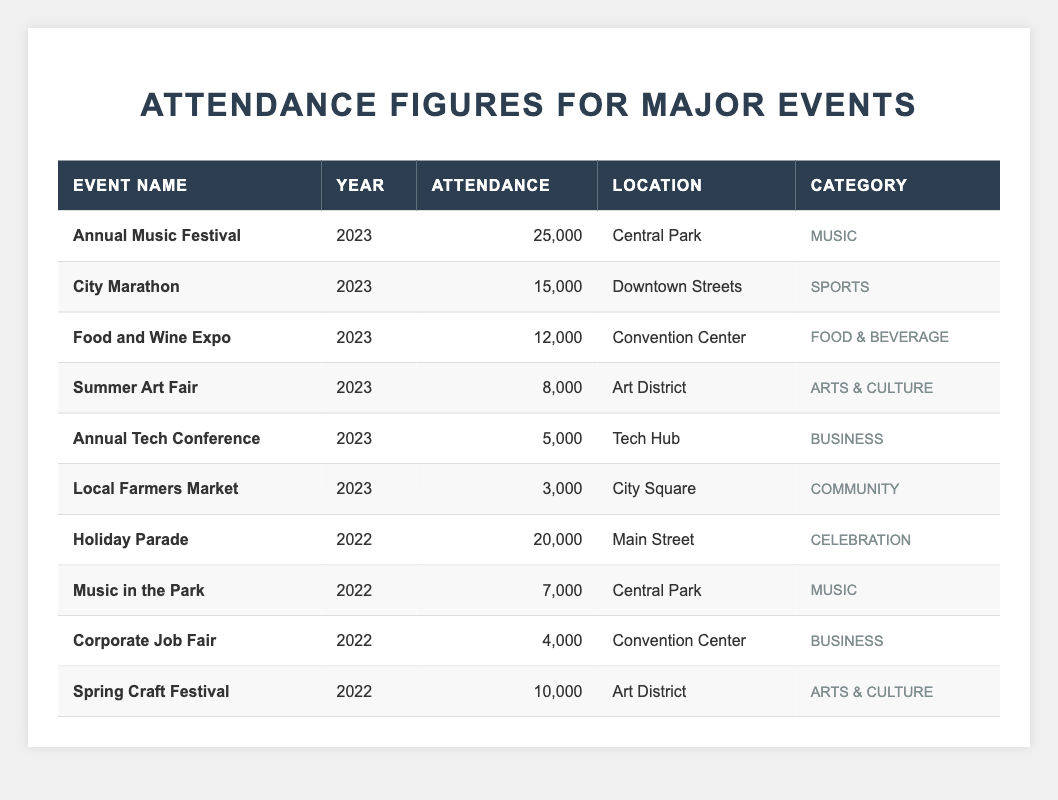What's the attendance for the Annual Music Festival in 2023? The attendance figure for the Annual Music Festival in 2023 can be found directly in the table under the "Attendance" column next to the event name. It shows a figure of 25,000.
Answer: 25,000 Which event had the highest attendance in 2022? By scanning the table, the Holiday Parade in 2022 shows the highest attendance of 20,000 when compared to other events that year.
Answer: 20,000 How many attendees were there at the Local Farmers Market in 2023? Looking at the entry for the Local Farmers Market under the year 2023, the attendance is specified as 3,000.
Answer: 3,000 What is the total attendance for all events held in 2023? To find the total attendance for events in 2023, we sum the attendance figures of each event: 25,000 (Annual Music Festival) + 15,000 (City Marathon) + 12,000 (Food and Wine Expo) + 8,000 (Summer Art Fair) + 5,000 (Annual Tech Conference) + 3,000 (Local Farmers Market) = 68,000.
Answer: 68,000 Did the City Marathon have more attendees than the Food and Wine Expo in 2023? In 2023, the City Marathon had 15,000 attendees, while the Food and Wine Expo had 12,000. Since 15,000 is greater than 12,000, the answer is yes.
Answer: Yes What is the average attendance for events in 2022? To calculate the average for 2022, we first sum the attendance figures: 20,000 (Holiday Parade) + 7,000 (Music in the Park) + 4,000 (Corporate Job Fair) + 10,000 (Spring Craft Festival) = 41,000. There are 4 events in 2022, so we divide the total by 4: 41,000 / 4 = 10,250.
Answer: 10,250 Which event took place in the Art District in 2023 and what was its attendance? The table shows that in 2023, the Summer Art Fair took place in the Art District with an attendance of 8,000.
Answer: Summer Art Fair, 8,000 How many attendees were there at the Corporate Job Fair compared to the Holiday Parade? The Corporate Job Fair had 4,000 attendees, while the Holiday Parade had 20,000 attendees. Therefore, the Holiday Parade had significantly more attendees.
Answer: Holiday Parade had more attendees What is the difference in attendance between the Annual Music Festival and the Annual Tech Conference in 2023? The attendance for the Annual Music Festival is 25,000 and for the Annual Tech Conference is 5,000. The difference can be calculated as 25,000 - 5,000 = 20,000.
Answer: 20,000 Were there any events in 2022 that had an attendance of more than 10,000? Yes, the Holiday Parade (20,000) and the Spring Craft Festival (10,000) both had attendances exceeding 10,000, with the Holiday Parade exceeding that figure.
Answer: Yes 